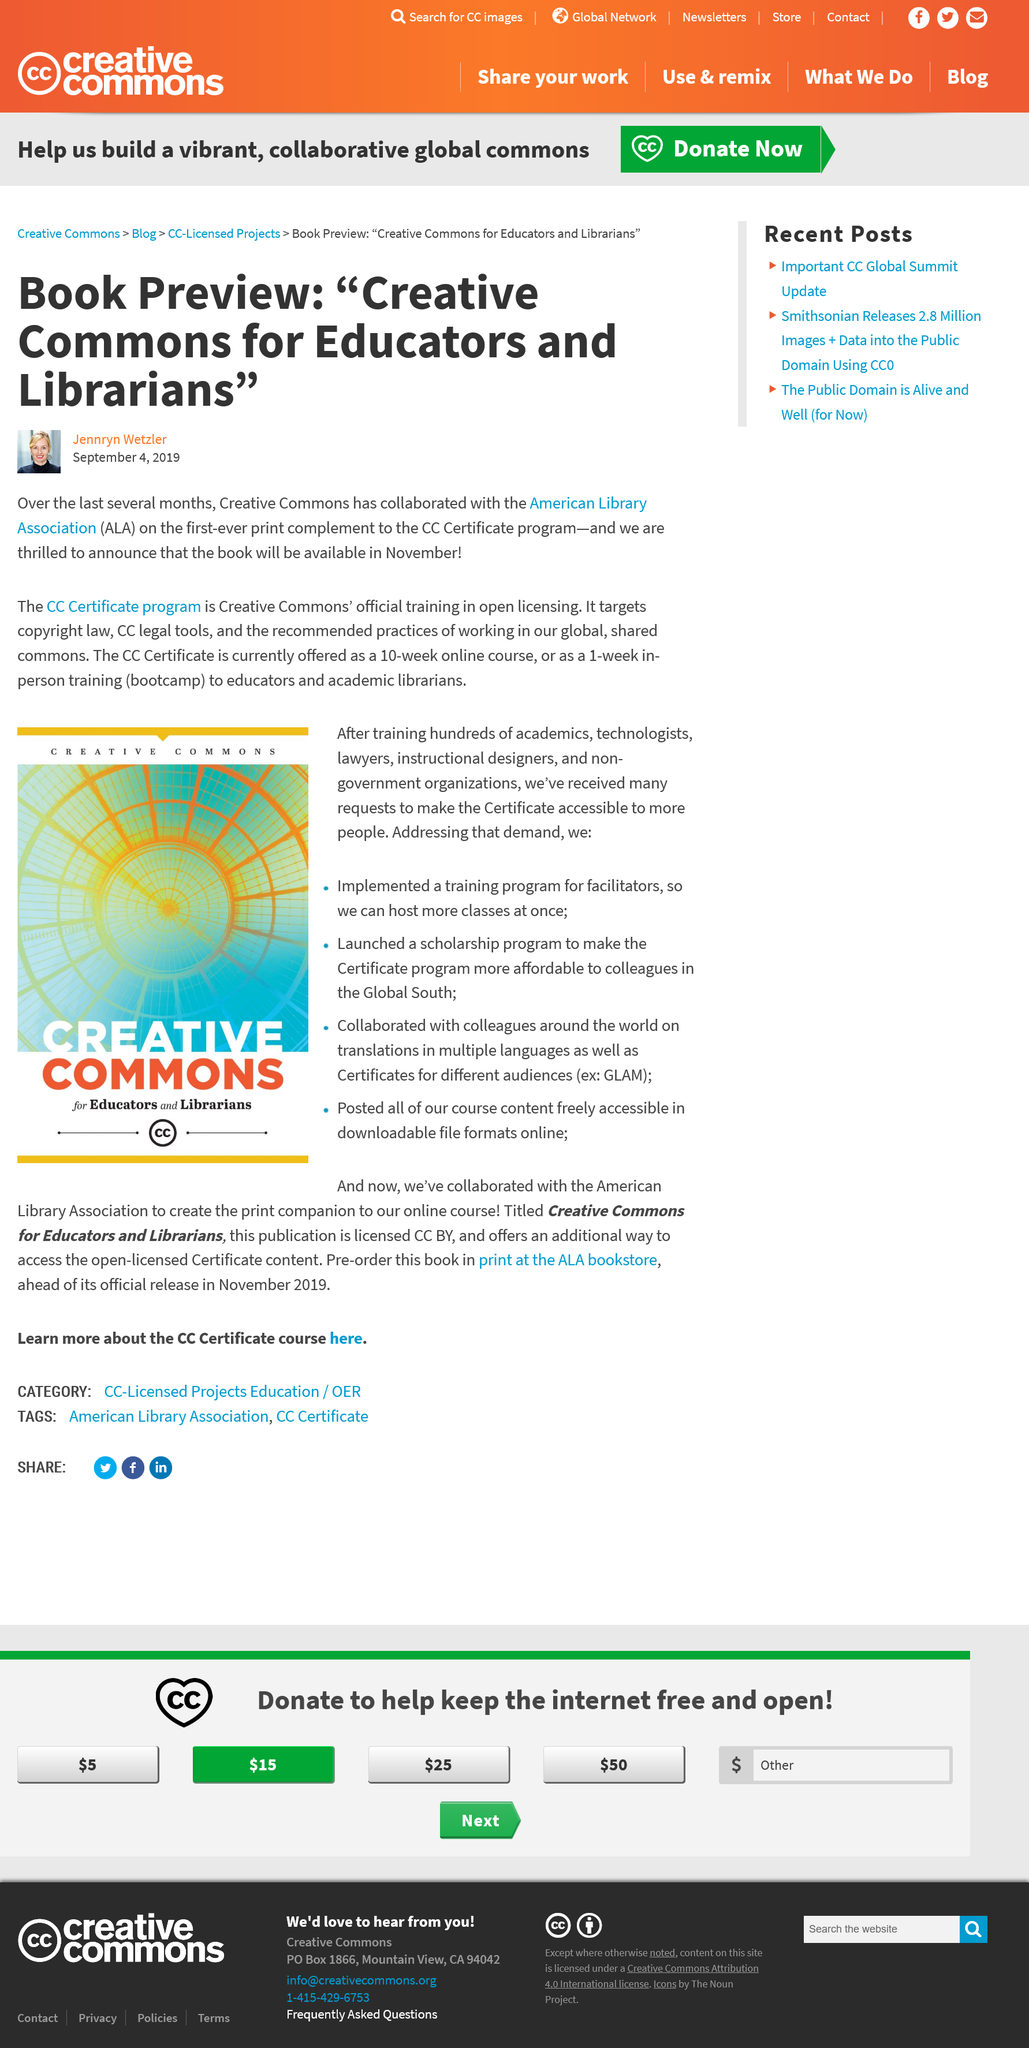Highlight a few significant elements in this photo. The print will be launched in November. The CC Certificate program lasts for 10 weeks, which is conducted entirely online, and is followed by a one-week in-person bootcamp. The Creative Commons, in collaboration with the American Library Association, created the CC Certificate program. 